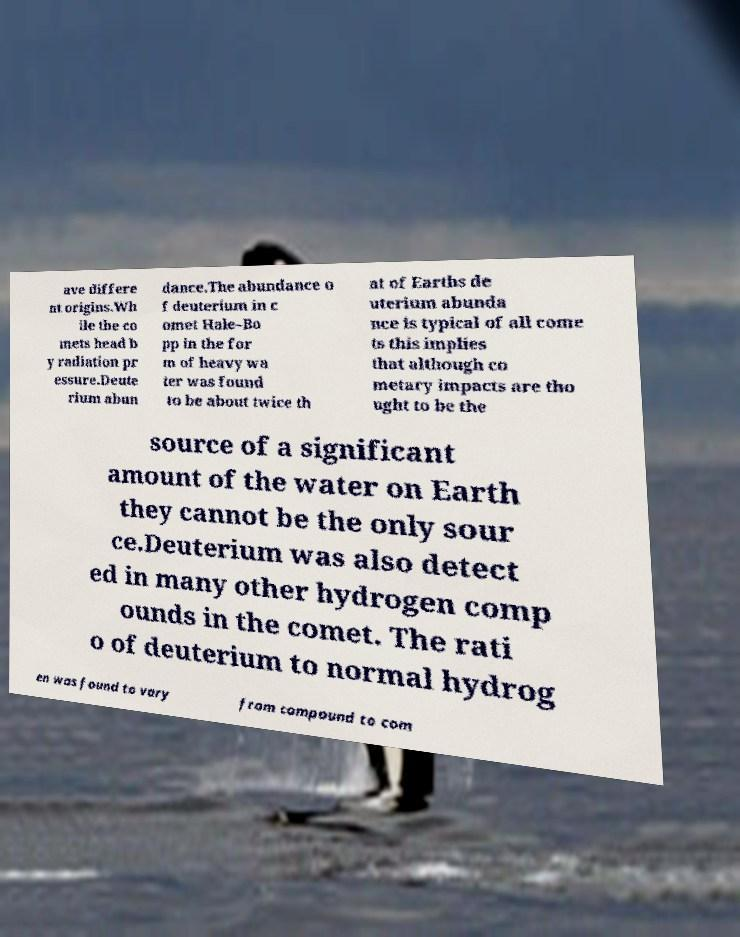There's text embedded in this image that I need extracted. Can you transcribe it verbatim? ave differe nt origins.Wh ile the co mets head b y radiation pr essure.Deute rium abun dance.The abundance o f deuterium in c omet Hale–Bo pp in the for m of heavy wa ter was found to be about twice th at of Earths de uterium abunda nce is typical of all come ts this implies that although co metary impacts are tho ught to be the source of a significant amount of the water on Earth they cannot be the only sour ce.Deuterium was also detect ed in many other hydrogen comp ounds in the comet. The rati o of deuterium to normal hydrog en was found to vary from compound to com 